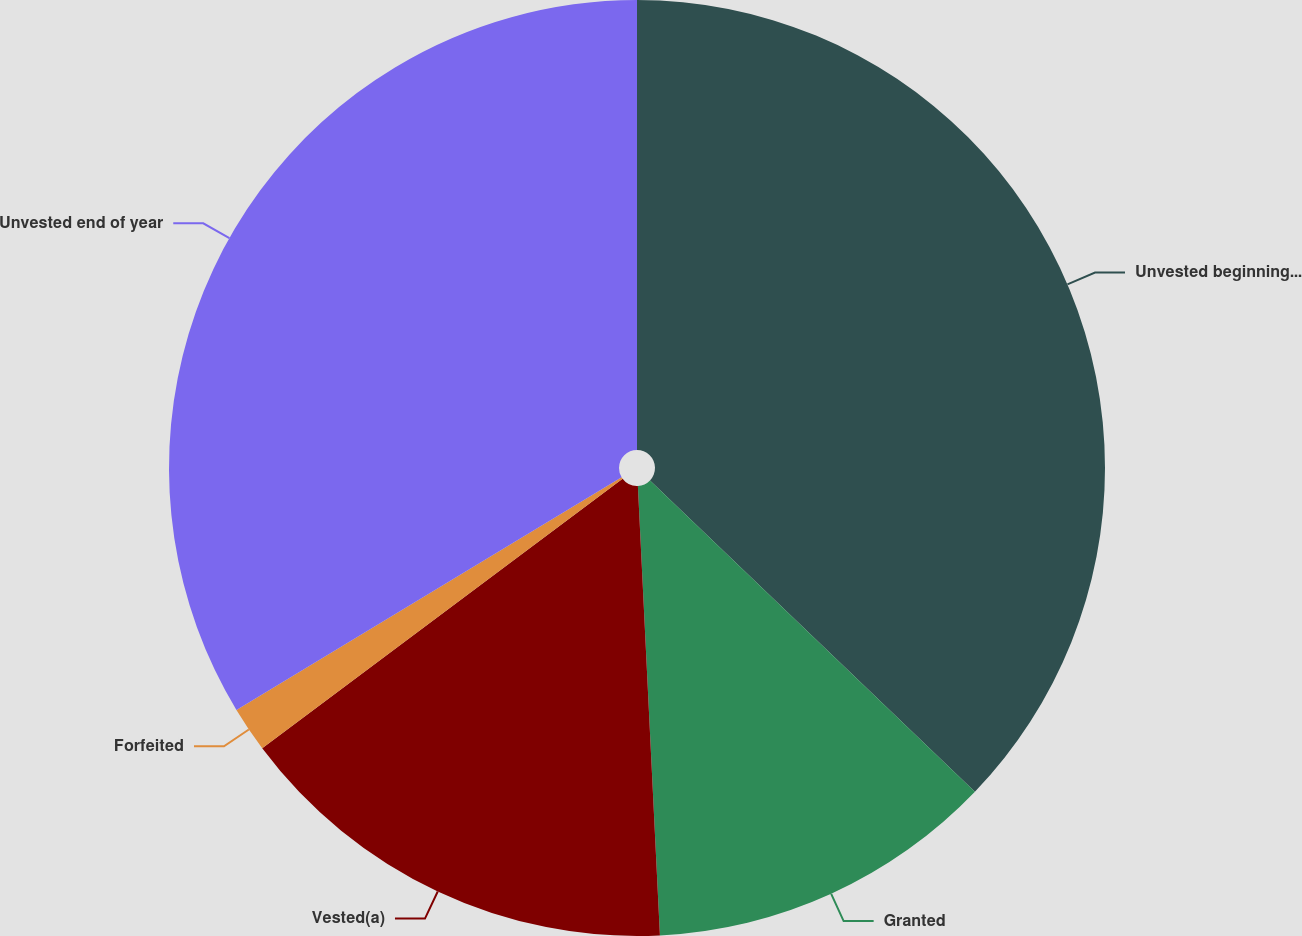Convert chart to OTSL. <chart><loc_0><loc_0><loc_500><loc_500><pie_chart><fcel>Unvested beginning of year<fcel>Granted<fcel>Vested(a)<fcel>Forfeited<fcel>Unvested end of year<nl><fcel>37.16%<fcel>12.06%<fcel>15.56%<fcel>1.57%<fcel>33.65%<nl></chart> 